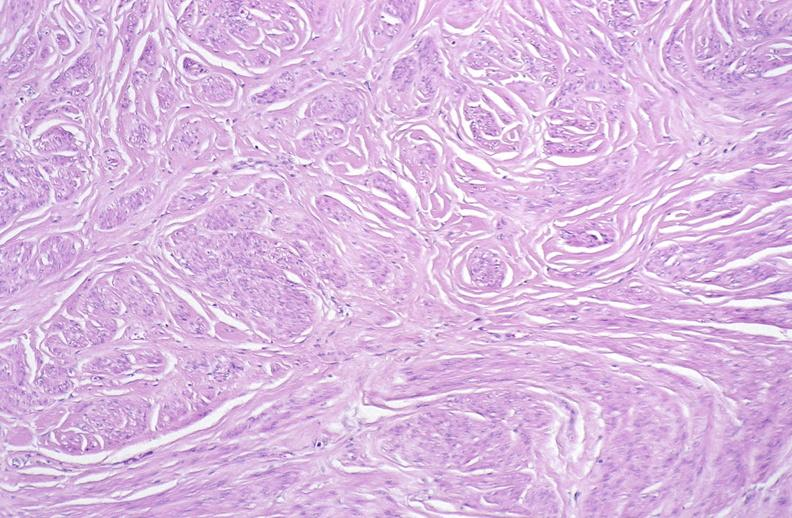s female reproductive present?
Answer the question using a single word or phrase. Yes 